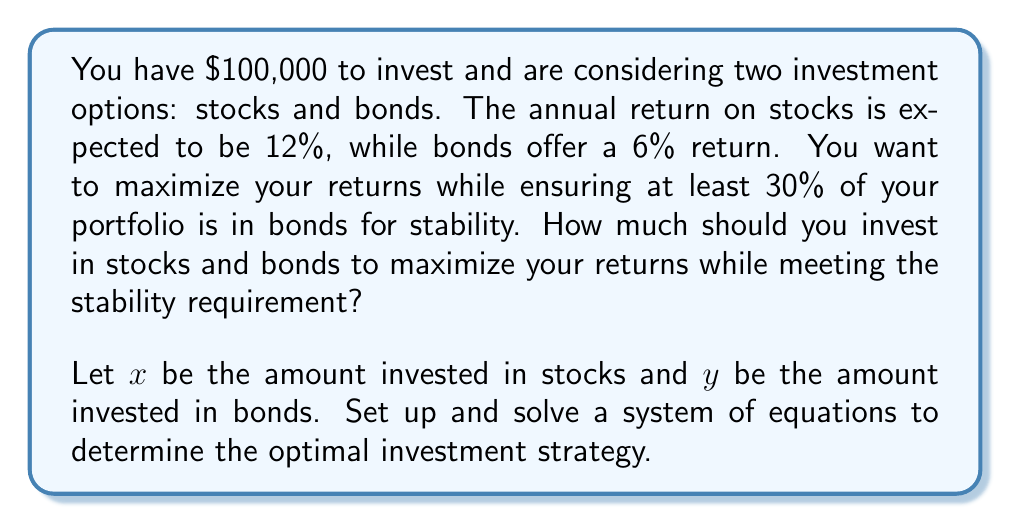Solve this math problem. Let's approach this step-by-step:

1) First, we need to set up our constraints:

   Total investment: $x + y = 100000$
   Bonds requirement: $y \geq 0.3(100000) = 30000$

2) Our objective is to maximize returns, which can be expressed as:

   $R = 0.12x + 0.06y$

3) Given the constraints, we want to maximize $x$ while keeping $y$ at its minimum allowed value:

   $y = 30000$
   $x = 100000 - y = 100000 - 30000 = 70000$

4) Let's verify this solution satisfies our system of equations:

   $x + y = 70000 + 30000 = 100000$ ✓
   $y = 30000 \geq 30000$ ✓

5) Calculate the total return:

   $R = 0.12(70000) + 0.06(30000) = 8400 + 1800 = 10200$

Therefore, to maximize returns while meeting the stability requirement, you should invest $70,000 in stocks and $30,000 in bonds, yielding a total annual return of $10,200.
Answer: Stocks: $70,000, Bonds: $30,000 